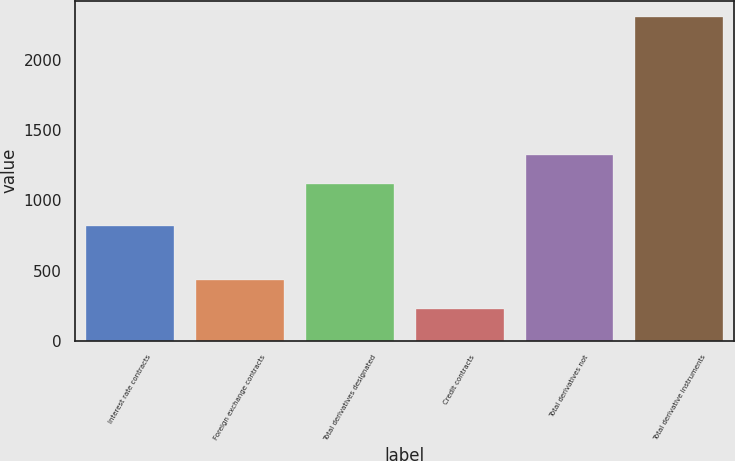Convert chart. <chart><loc_0><loc_0><loc_500><loc_500><bar_chart><fcel>Interest rate contracts<fcel>Foreign exchange contracts<fcel>Total derivatives designated<fcel>Credit contracts<fcel>Total derivatives not<fcel>Total derivative instruments<nl><fcel>819.2<fcel>435.34<fcel>1119.6<fcel>227.2<fcel>1327.74<fcel>2308.6<nl></chart> 